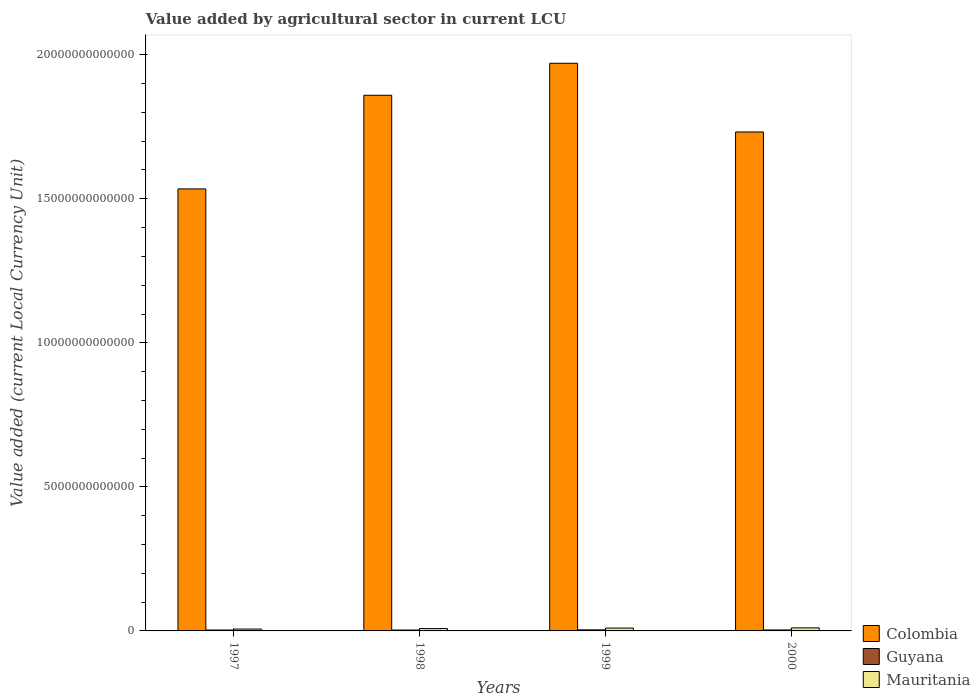Are the number of bars per tick equal to the number of legend labels?
Keep it short and to the point. Yes. Are the number of bars on each tick of the X-axis equal?
Provide a short and direct response. Yes. How many bars are there on the 1st tick from the left?
Your response must be concise. 3. How many bars are there on the 2nd tick from the right?
Your answer should be very brief. 3. What is the label of the 4th group of bars from the left?
Ensure brevity in your answer.  2000. What is the value added by agricultural sector in Mauritania in 1999?
Give a very brief answer. 9.96e+1. Across all years, what is the maximum value added by agricultural sector in Mauritania?
Keep it short and to the point. 1.06e+11. Across all years, what is the minimum value added by agricultural sector in Guyana?
Make the answer very short. 3.13e+1. What is the total value added by agricultural sector in Mauritania in the graph?
Your answer should be compact. 3.52e+11. What is the difference between the value added by agricultural sector in Colombia in 1997 and that in 2000?
Provide a succinct answer. -1.98e+12. What is the difference between the value added by agricultural sector in Mauritania in 2000 and the value added by agricultural sector in Guyana in 1998?
Keep it short and to the point. 7.49e+1. What is the average value added by agricultural sector in Colombia per year?
Your response must be concise. 1.77e+13. In the year 1999, what is the difference between the value added by agricultural sector in Mauritania and value added by agricultural sector in Guyana?
Offer a very short reply. 6.32e+1. In how many years, is the value added by agricultural sector in Guyana greater than 9000000000000 LCU?
Your answer should be very brief. 0. What is the ratio of the value added by agricultural sector in Colombia in 1998 to that in 1999?
Keep it short and to the point. 0.94. What is the difference between the highest and the second highest value added by agricultural sector in Colombia?
Your answer should be compact. 1.11e+12. What is the difference between the highest and the lowest value added by agricultural sector in Colombia?
Your answer should be very brief. 4.36e+12. In how many years, is the value added by agricultural sector in Colombia greater than the average value added by agricultural sector in Colombia taken over all years?
Your answer should be compact. 2. Is the sum of the value added by agricultural sector in Guyana in 1997 and 1998 greater than the maximum value added by agricultural sector in Colombia across all years?
Ensure brevity in your answer.  No. What does the 3rd bar from the left in 1999 represents?
Your response must be concise. Mauritania. What does the 2nd bar from the right in 2000 represents?
Your answer should be very brief. Guyana. Are all the bars in the graph horizontal?
Your response must be concise. No. How many years are there in the graph?
Ensure brevity in your answer.  4. What is the difference between two consecutive major ticks on the Y-axis?
Provide a short and direct response. 5.00e+12. Are the values on the major ticks of Y-axis written in scientific E-notation?
Your answer should be very brief. No. Does the graph contain grids?
Offer a terse response. No. How many legend labels are there?
Your response must be concise. 3. How are the legend labels stacked?
Offer a very short reply. Vertical. What is the title of the graph?
Provide a short and direct response. Value added by agricultural sector in current LCU. What is the label or title of the Y-axis?
Provide a short and direct response. Value added (current Local Currency Unit). What is the Value added (current Local Currency Unit) of Colombia in 1997?
Provide a succinct answer. 1.53e+13. What is the Value added (current Local Currency Unit) in Guyana in 1997?
Keep it short and to the point. 3.18e+1. What is the Value added (current Local Currency Unit) in Mauritania in 1997?
Provide a short and direct response. 6.47e+1. What is the Value added (current Local Currency Unit) in Colombia in 1998?
Provide a succinct answer. 1.86e+13. What is the Value added (current Local Currency Unit) in Guyana in 1998?
Your answer should be compact. 3.13e+1. What is the Value added (current Local Currency Unit) in Mauritania in 1998?
Offer a terse response. 8.16e+1. What is the Value added (current Local Currency Unit) in Colombia in 1999?
Ensure brevity in your answer.  1.97e+13. What is the Value added (current Local Currency Unit) in Guyana in 1999?
Give a very brief answer. 3.64e+1. What is the Value added (current Local Currency Unit) in Mauritania in 1999?
Offer a very short reply. 9.96e+1. What is the Value added (current Local Currency Unit) in Colombia in 2000?
Your answer should be compact. 1.73e+13. What is the Value added (current Local Currency Unit) of Guyana in 2000?
Ensure brevity in your answer.  3.36e+1. What is the Value added (current Local Currency Unit) of Mauritania in 2000?
Keep it short and to the point. 1.06e+11. Across all years, what is the maximum Value added (current Local Currency Unit) in Colombia?
Your response must be concise. 1.97e+13. Across all years, what is the maximum Value added (current Local Currency Unit) in Guyana?
Offer a very short reply. 3.64e+1. Across all years, what is the maximum Value added (current Local Currency Unit) of Mauritania?
Keep it short and to the point. 1.06e+11. Across all years, what is the minimum Value added (current Local Currency Unit) of Colombia?
Keep it short and to the point. 1.53e+13. Across all years, what is the minimum Value added (current Local Currency Unit) of Guyana?
Make the answer very short. 3.13e+1. Across all years, what is the minimum Value added (current Local Currency Unit) in Mauritania?
Ensure brevity in your answer.  6.47e+1. What is the total Value added (current Local Currency Unit) of Colombia in the graph?
Your answer should be compact. 7.10e+13. What is the total Value added (current Local Currency Unit) of Guyana in the graph?
Make the answer very short. 1.33e+11. What is the total Value added (current Local Currency Unit) in Mauritania in the graph?
Your answer should be very brief. 3.52e+11. What is the difference between the Value added (current Local Currency Unit) in Colombia in 1997 and that in 1998?
Give a very brief answer. -3.25e+12. What is the difference between the Value added (current Local Currency Unit) of Guyana in 1997 and that in 1998?
Make the answer very short. 5.04e+08. What is the difference between the Value added (current Local Currency Unit) in Mauritania in 1997 and that in 1998?
Your response must be concise. -1.69e+1. What is the difference between the Value added (current Local Currency Unit) of Colombia in 1997 and that in 1999?
Your answer should be compact. -4.36e+12. What is the difference between the Value added (current Local Currency Unit) of Guyana in 1997 and that in 1999?
Ensure brevity in your answer.  -4.59e+09. What is the difference between the Value added (current Local Currency Unit) of Mauritania in 1997 and that in 1999?
Provide a succinct answer. -3.49e+1. What is the difference between the Value added (current Local Currency Unit) of Colombia in 1997 and that in 2000?
Make the answer very short. -1.98e+12. What is the difference between the Value added (current Local Currency Unit) in Guyana in 1997 and that in 2000?
Keep it short and to the point. -1.79e+09. What is the difference between the Value added (current Local Currency Unit) of Mauritania in 1997 and that in 2000?
Provide a succinct answer. -4.15e+1. What is the difference between the Value added (current Local Currency Unit) of Colombia in 1998 and that in 1999?
Offer a very short reply. -1.11e+12. What is the difference between the Value added (current Local Currency Unit) in Guyana in 1998 and that in 1999?
Offer a terse response. -5.10e+09. What is the difference between the Value added (current Local Currency Unit) in Mauritania in 1998 and that in 1999?
Your answer should be very brief. -1.81e+1. What is the difference between the Value added (current Local Currency Unit) in Colombia in 1998 and that in 2000?
Keep it short and to the point. 1.27e+12. What is the difference between the Value added (current Local Currency Unit) in Guyana in 1998 and that in 2000?
Provide a succinct answer. -2.29e+09. What is the difference between the Value added (current Local Currency Unit) in Mauritania in 1998 and that in 2000?
Your answer should be very brief. -2.46e+1. What is the difference between the Value added (current Local Currency Unit) in Colombia in 1999 and that in 2000?
Offer a very short reply. 2.38e+12. What is the difference between the Value added (current Local Currency Unit) of Guyana in 1999 and that in 2000?
Give a very brief answer. 2.80e+09. What is the difference between the Value added (current Local Currency Unit) of Mauritania in 1999 and that in 2000?
Your response must be concise. -6.59e+09. What is the difference between the Value added (current Local Currency Unit) of Colombia in 1997 and the Value added (current Local Currency Unit) of Guyana in 1998?
Offer a terse response. 1.53e+13. What is the difference between the Value added (current Local Currency Unit) of Colombia in 1997 and the Value added (current Local Currency Unit) of Mauritania in 1998?
Give a very brief answer. 1.53e+13. What is the difference between the Value added (current Local Currency Unit) of Guyana in 1997 and the Value added (current Local Currency Unit) of Mauritania in 1998?
Your response must be concise. -4.98e+1. What is the difference between the Value added (current Local Currency Unit) in Colombia in 1997 and the Value added (current Local Currency Unit) in Guyana in 1999?
Keep it short and to the point. 1.53e+13. What is the difference between the Value added (current Local Currency Unit) in Colombia in 1997 and the Value added (current Local Currency Unit) in Mauritania in 1999?
Your answer should be compact. 1.52e+13. What is the difference between the Value added (current Local Currency Unit) in Guyana in 1997 and the Value added (current Local Currency Unit) in Mauritania in 1999?
Provide a succinct answer. -6.78e+1. What is the difference between the Value added (current Local Currency Unit) in Colombia in 1997 and the Value added (current Local Currency Unit) in Guyana in 2000?
Your answer should be compact. 1.53e+13. What is the difference between the Value added (current Local Currency Unit) of Colombia in 1997 and the Value added (current Local Currency Unit) of Mauritania in 2000?
Give a very brief answer. 1.52e+13. What is the difference between the Value added (current Local Currency Unit) in Guyana in 1997 and the Value added (current Local Currency Unit) in Mauritania in 2000?
Offer a terse response. -7.44e+1. What is the difference between the Value added (current Local Currency Unit) of Colombia in 1998 and the Value added (current Local Currency Unit) of Guyana in 1999?
Offer a very short reply. 1.86e+13. What is the difference between the Value added (current Local Currency Unit) of Colombia in 1998 and the Value added (current Local Currency Unit) of Mauritania in 1999?
Make the answer very short. 1.85e+13. What is the difference between the Value added (current Local Currency Unit) of Guyana in 1998 and the Value added (current Local Currency Unit) of Mauritania in 1999?
Keep it short and to the point. -6.83e+1. What is the difference between the Value added (current Local Currency Unit) of Colombia in 1998 and the Value added (current Local Currency Unit) of Guyana in 2000?
Provide a short and direct response. 1.86e+13. What is the difference between the Value added (current Local Currency Unit) in Colombia in 1998 and the Value added (current Local Currency Unit) in Mauritania in 2000?
Offer a terse response. 1.85e+13. What is the difference between the Value added (current Local Currency Unit) of Guyana in 1998 and the Value added (current Local Currency Unit) of Mauritania in 2000?
Provide a succinct answer. -7.49e+1. What is the difference between the Value added (current Local Currency Unit) in Colombia in 1999 and the Value added (current Local Currency Unit) in Guyana in 2000?
Your answer should be compact. 1.97e+13. What is the difference between the Value added (current Local Currency Unit) of Colombia in 1999 and the Value added (current Local Currency Unit) of Mauritania in 2000?
Offer a terse response. 1.96e+13. What is the difference between the Value added (current Local Currency Unit) of Guyana in 1999 and the Value added (current Local Currency Unit) of Mauritania in 2000?
Your answer should be very brief. -6.98e+1. What is the average Value added (current Local Currency Unit) of Colombia per year?
Give a very brief answer. 1.77e+13. What is the average Value added (current Local Currency Unit) of Guyana per year?
Provide a succinct answer. 3.33e+1. What is the average Value added (current Local Currency Unit) of Mauritania per year?
Your answer should be very brief. 8.80e+1. In the year 1997, what is the difference between the Value added (current Local Currency Unit) of Colombia and Value added (current Local Currency Unit) of Guyana?
Provide a succinct answer. 1.53e+13. In the year 1997, what is the difference between the Value added (current Local Currency Unit) in Colombia and Value added (current Local Currency Unit) in Mauritania?
Give a very brief answer. 1.53e+13. In the year 1997, what is the difference between the Value added (current Local Currency Unit) in Guyana and Value added (current Local Currency Unit) in Mauritania?
Keep it short and to the point. -3.29e+1. In the year 1998, what is the difference between the Value added (current Local Currency Unit) in Colombia and Value added (current Local Currency Unit) in Guyana?
Provide a short and direct response. 1.86e+13. In the year 1998, what is the difference between the Value added (current Local Currency Unit) of Colombia and Value added (current Local Currency Unit) of Mauritania?
Ensure brevity in your answer.  1.85e+13. In the year 1998, what is the difference between the Value added (current Local Currency Unit) of Guyana and Value added (current Local Currency Unit) of Mauritania?
Your response must be concise. -5.03e+1. In the year 1999, what is the difference between the Value added (current Local Currency Unit) in Colombia and Value added (current Local Currency Unit) in Guyana?
Make the answer very short. 1.97e+13. In the year 1999, what is the difference between the Value added (current Local Currency Unit) in Colombia and Value added (current Local Currency Unit) in Mauritania?
Keep it short and to the point. 1.96e+13. In the year 1999, what is the difference between the Value added (current Local Currency Unit) of Guyana and Value added (current Local Currency Unit) of Mauritania?
Your response must be concise. -6.32e+1. In the year 2000, what is the difference between the Value added (current Local Currency Unit) in Colombia and Value added (current Local Currency Unit) in Guyana?
Your answer should be very brief. 1.73e+13. In the year 2000, what is the difference between the Value added (current Local Currency Unit) of Colombia and Value added (current Local Currency Unit) of Mauritania?
Offer a terse response. 1.72e+13. In the year 2000, what is the difference between the Value added (current Local Currency Unit) in Guyana and Value added (current Local Currency Unit) in Mauritania?
Offer a very short reply. -7.26e+1. What is the ratio of the Value added (current Local Currency Unit) of Colombia in 1997 to that in 1998?
Provide a short and direct response. 0.83. What is the ratio of the Value added (current Local Currency Unit) of Guyana in 1997 to that in 1998?
Your answer should be compact. 1.02. What is the ratio of the Value added (current Local Currency Unit) of Mauritania in 1997 to that in 1998?
Make the answer very short. 0.79. What is the ratio of the Value added (current Local Currency Unit) in Colombia in 1997 to that in 1999?
Your answer should be very brief. 0.78. What is the ratio of the Value added (current Local Currency Unit) of Guyana in 1997 to that in 1999?
Your answer should be compact. 0.87. What is the ratio of the Value added (current Local Currency Unit) in Mauritania in 1997 to that in 1999?
Your answer should be compact. 0.65. What is the ratio of the Value added (current Local Currency Unit) of Colombia in 1997 to that in 2000?
Make the answer very short. 0.89. What is the ratio of the Value added (current Local Currency Unit) in Guyana in 1997 to that in 2000?
Your answer should be very brief. 0.95. What is the ratio of the Value added (current Local Currency Unit) in Mauritania in 1997 to that in 2000?
Give a very brief answer. 0.61. What is the ratio of the Value added (current Local Currency Unit) of Colombia in 1998 to that in 1999?
Provide a short and direct response. 0.94. What is the ratio of the Value added (current Local Currency Unit) in Guyana in 1998 to that in 1999?
Offer a very short reply. 0.86. What is the ratio of the Value added (current Local Currency Unit) in Mauritania in 1998 to that in 1999?
Your response must be concise. 0.82. What is the ratio of the Value added (current Local Currency Unit) of Colombia in 1998 to that in 2000?
Your response must be concise. 1.07. What is the ratio of the Value added (current Local Currency Unit) of Guyana in 1998 to that in 2000?
Your answer should be very brief. 0.93. What is the ratio of the Value added (current Local Currency Unit) of Mauritania in 1998 to that in 2000?
Offer a terse response. 0.77. What is the ratio of the Value added (current Local Currency Unit) in Colombia in 1999 to that in 2000?
Make the answer very short. 1.14. What is the ratio of the Value added (current Local Currency Unit) of Guyana in 1999 to that in 2000?
Give a very brief answer. 1.08. What is the ratio of the Value added (current Local Currency Unit) in Mauritania in 1999 to that in 2000?
Your answer should be very brief. 0.94. What is the difference between the highest and the second highest Value added (current Local Currency Unit) of Colombia?
Give a very brief answer. 1.11e+12. What is the difference between the highest and the second highest Value added (current Local Currency Unit) in Guyana?
Provide a succinct answer. 2.80e+09. What is the difference between the highest and the second highest Value added (current Local Currency Unit) of Mauritania?
Your answer should be compact. 6.59e+09. What is the difference between the highest and the lowest Value added (current Local Currency Unit) of Colombia?
Give a very brief answer. 4.36e+12. What is the difference between the highest and the lowest Value added (current Local Currency Unit) in Guyana?
Offer a terse response. 5.10e+09. What is the difference between the highest and the lowest Value added (current Local Currency Unit) in Mauritania?
Provide a succinct answer. 4.15e+1. 